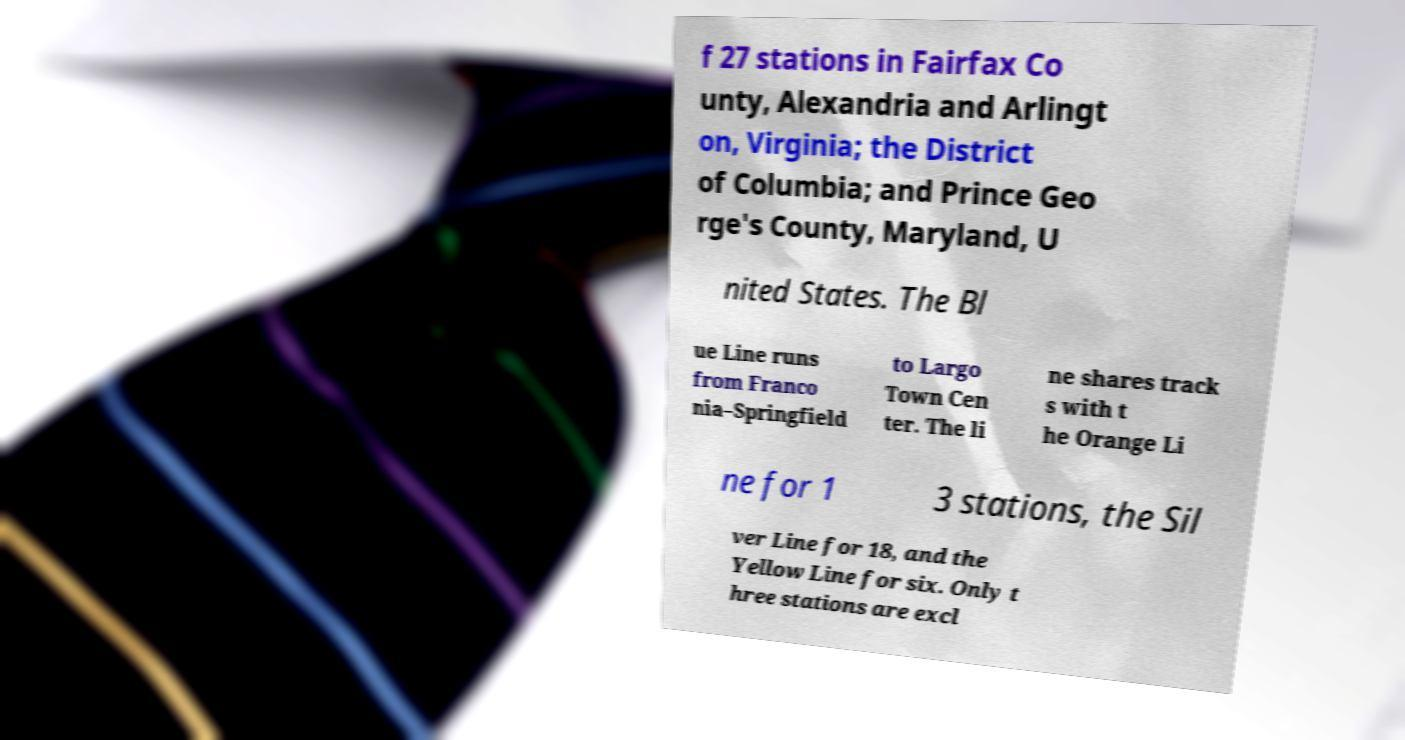Can you read and provide the text displayed in the image?This photo seems to have some interesting text. Can you extract and type it out for me? f 27 stations in Fairfax Co unty, Alexandria and Arlingt on, Virginia; the District of Columbia; and Prince Geo rge's County, Maryland, U nited States. The Bl ue Line runs from Franco nia–Springfield to Largo Town Cen ter. The li ne shares track s with t he Orange Li ne for 1 3 stations, the Sil ver Line for 18, and the Yellow Line for six. Only t hree stations are excl 